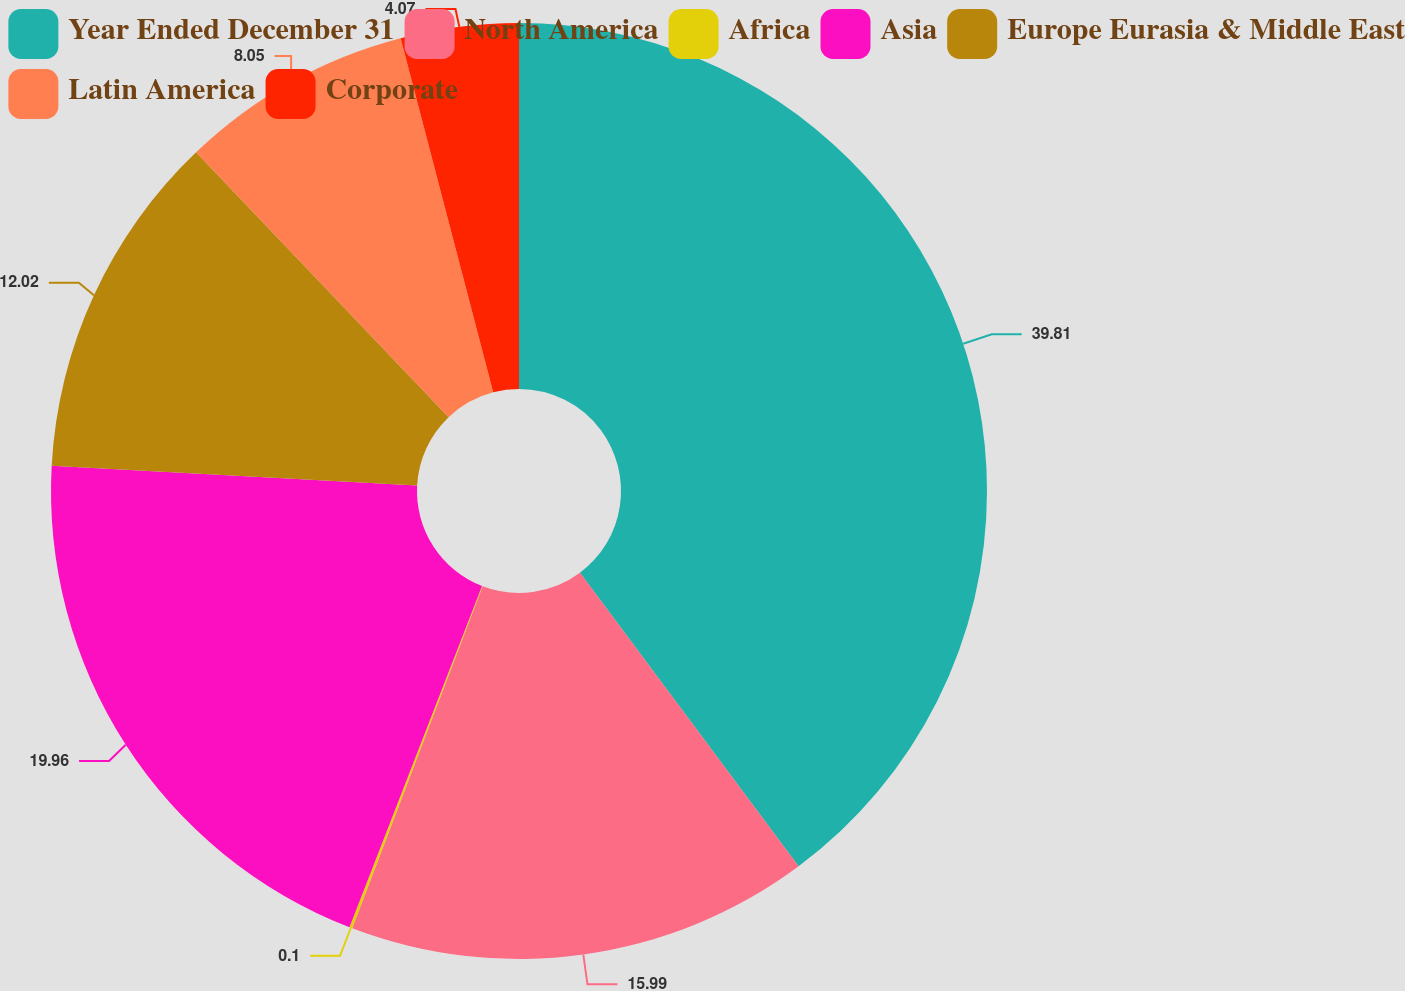Convert chart to OTSL. <chart><loc_0><loc_0><loc_500><loc_500><pie_chart><fcel>Year Ended December 31<fcel>North America<fcel>Africa<fcel>Asia<fcel>Europe Eurasia & Middle East<fcel>Latin America<fcel>Corporate<nl><fcel>39.81%<fcel>15.99%<fcel>0.1%<fcel>19.96%<fcel>12.02%<fcel>8.05%<fcel>4.07%<nl></chart> 